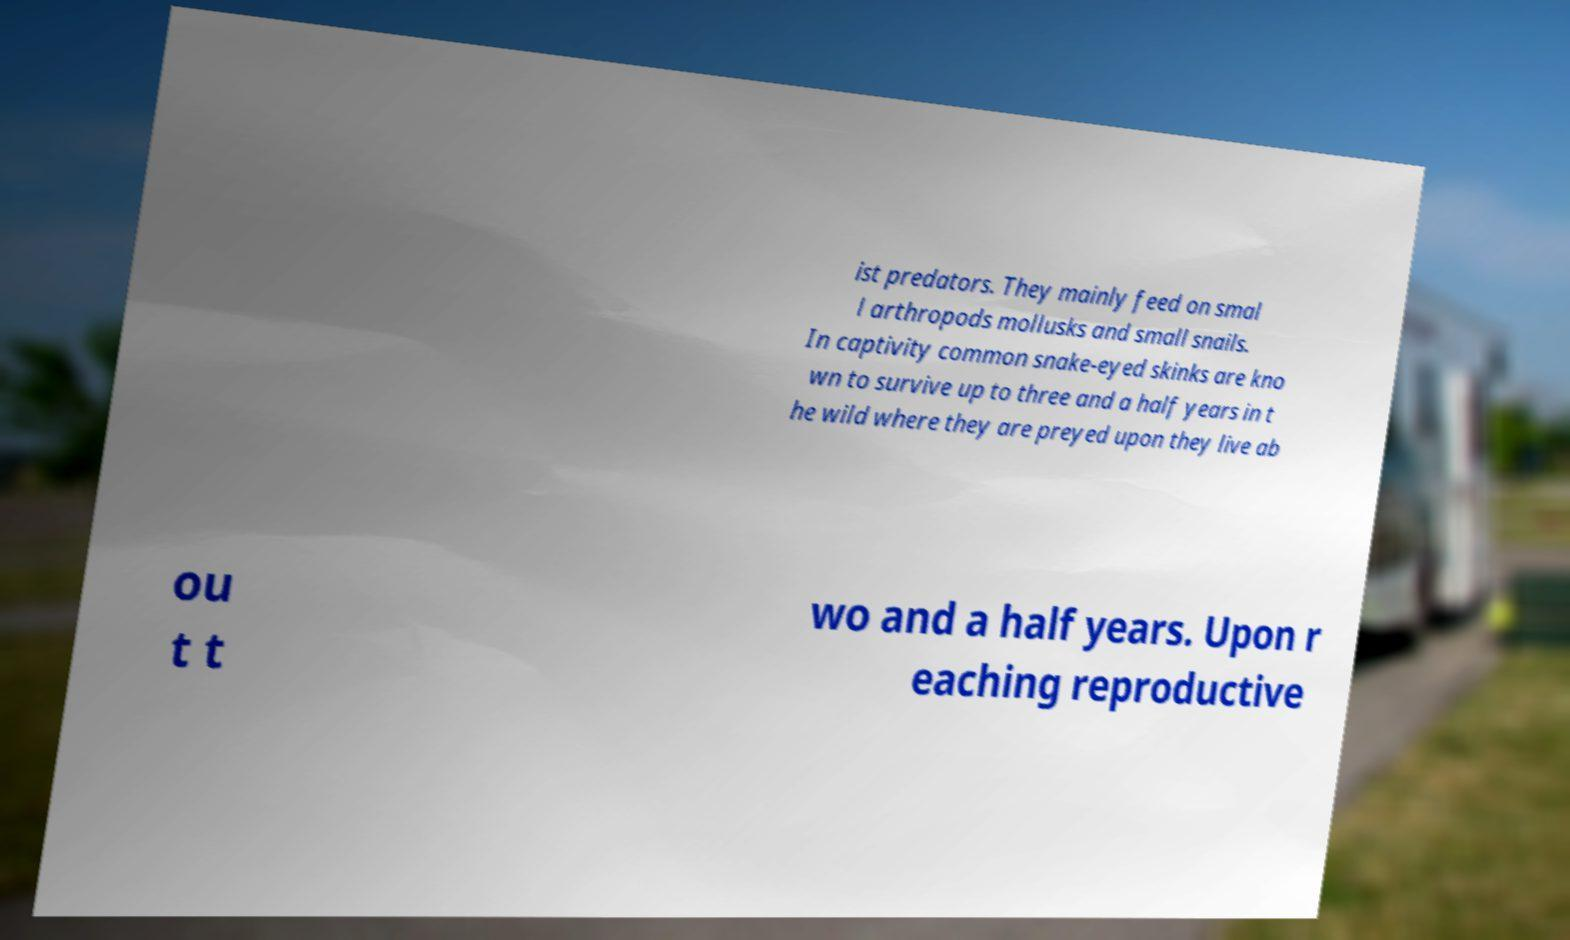Can you accurately transcribe the text from the provided image for me? ist predators. They mainly feed on smal l arthropods mollusks and small snails. In captivity common snake-eyed skinks are kno wn to survive up to three and a half years in t he wild where they are preyed upon they live ab ou t t wo and a half years. Upon r eaching reproductive 